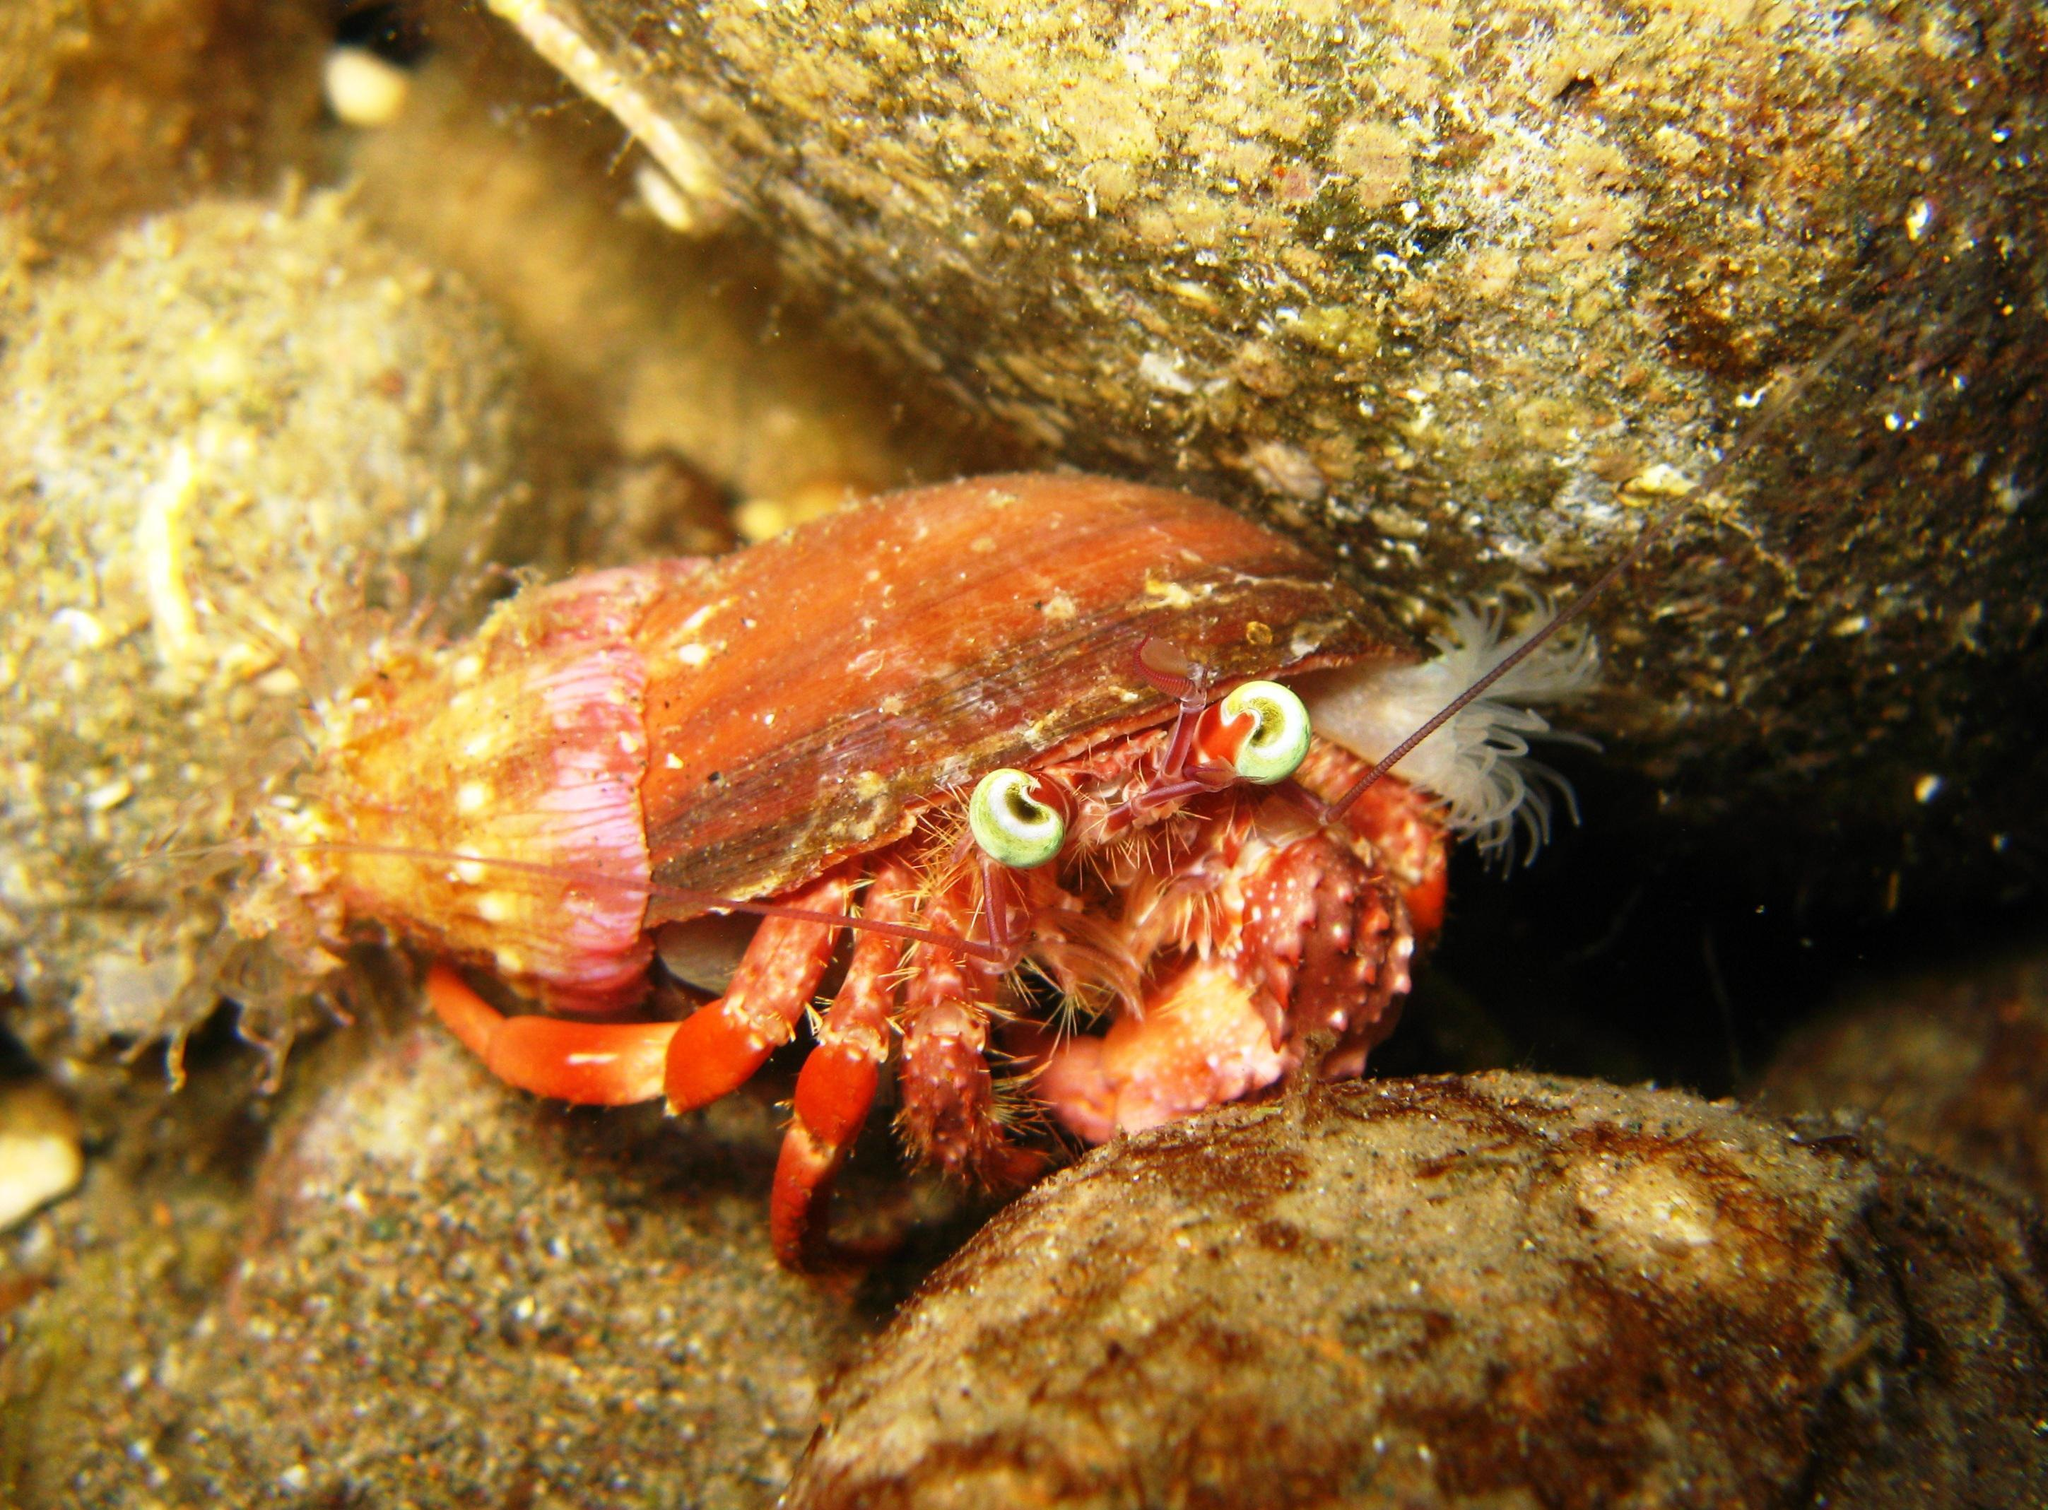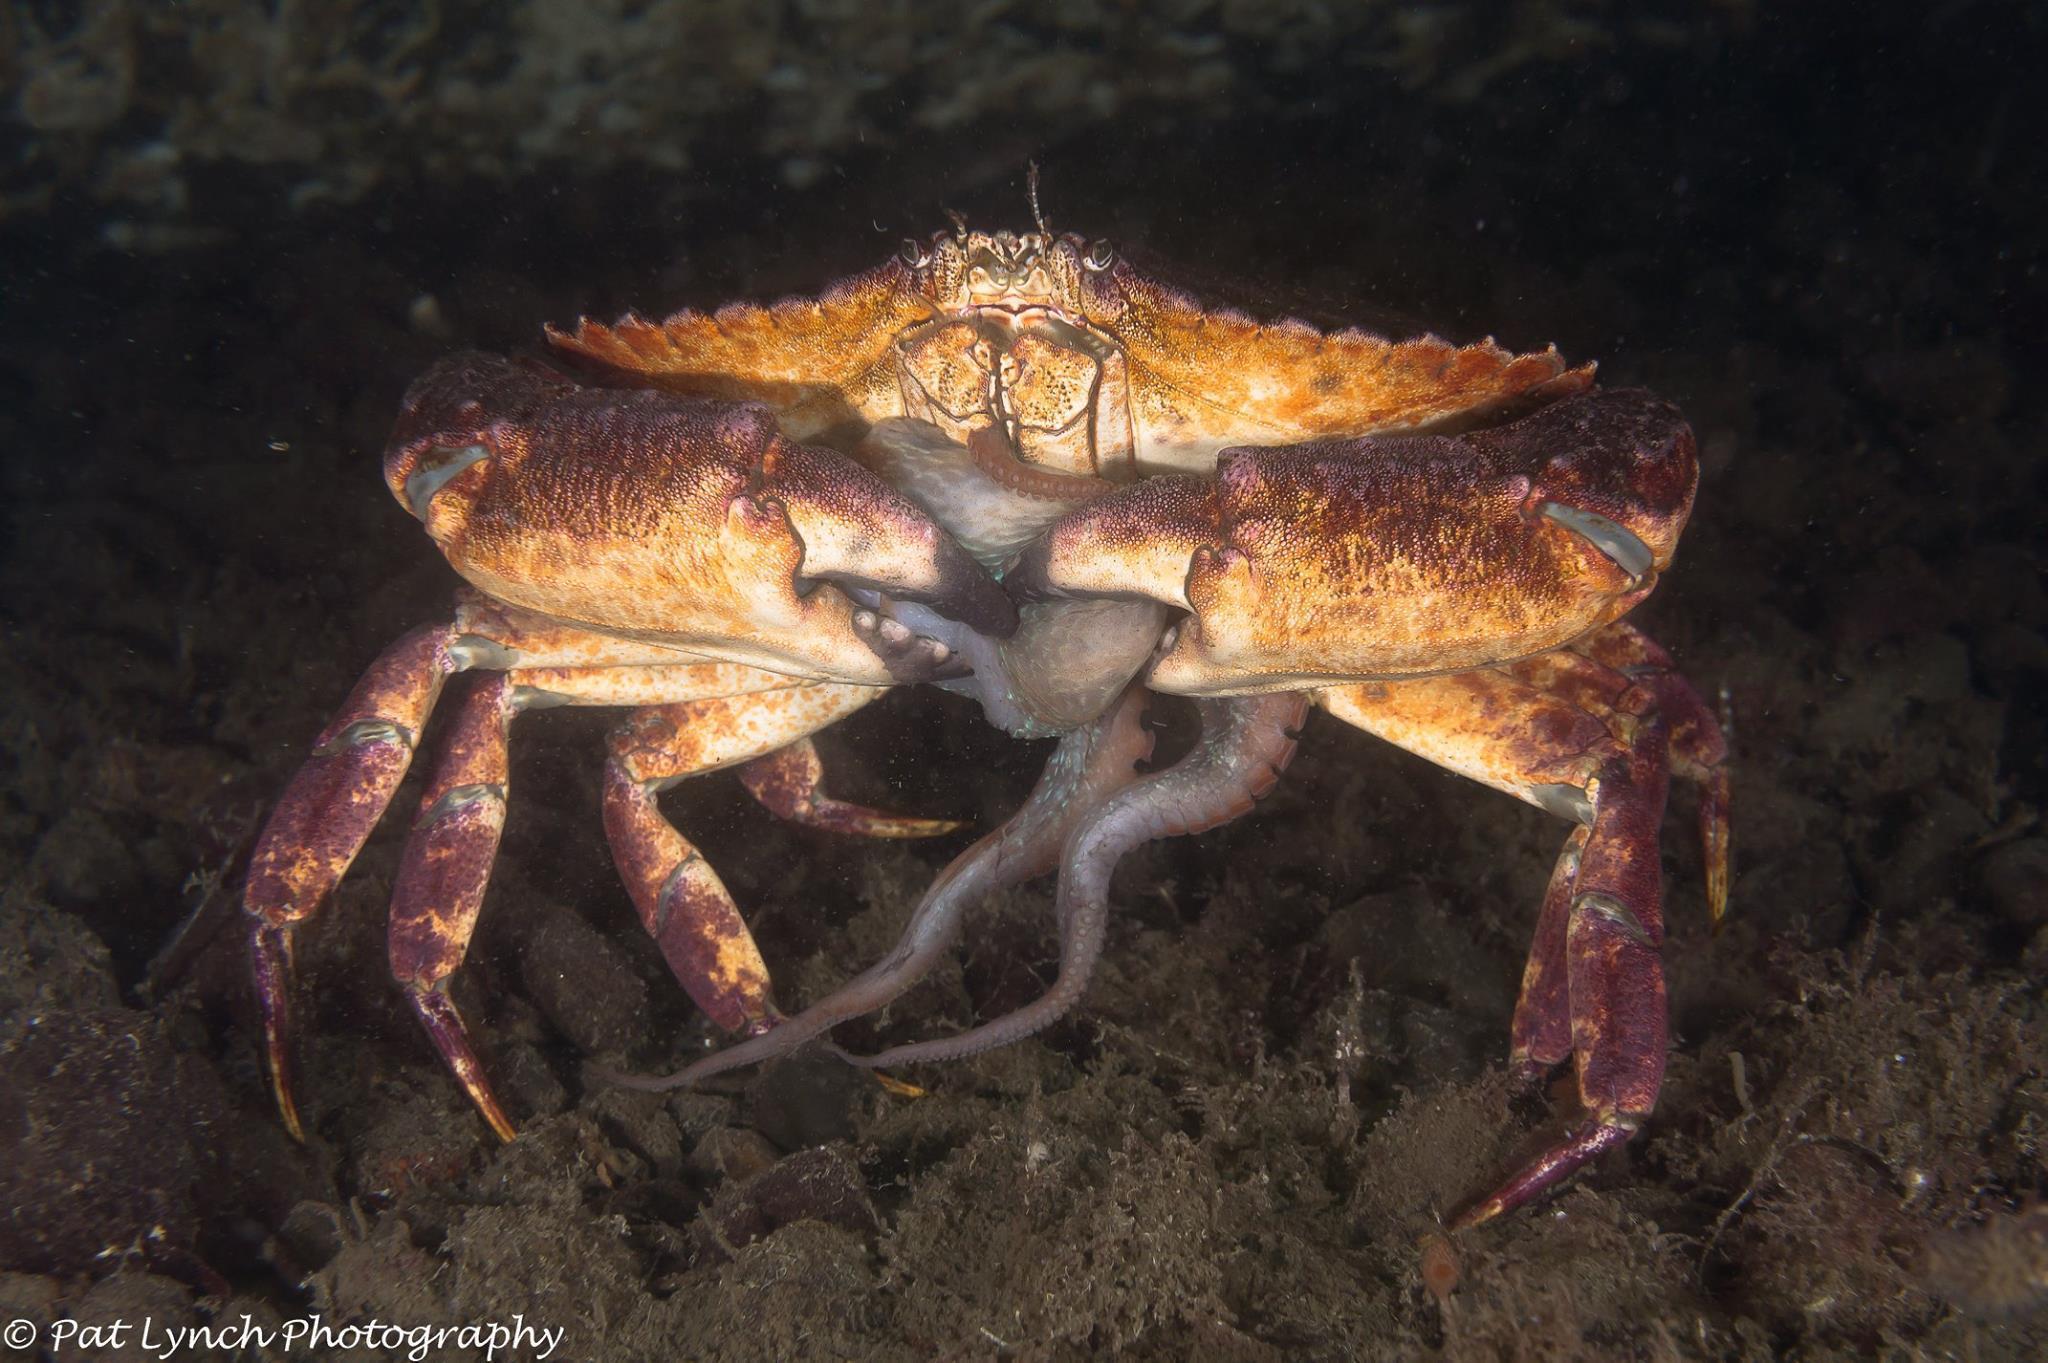The first image is the image on the left, the second image is the image on the right. Examine the images to the left and right. Is the description "there are two crabs in the image pair" accurate? Answer yes or no. Yes. The first image is the image on the left, the second image is the image on the right. For the images shown, is this caption "A single crab sits on the bottom of the water in each of the images." true? Answer yes or no. Yes. 